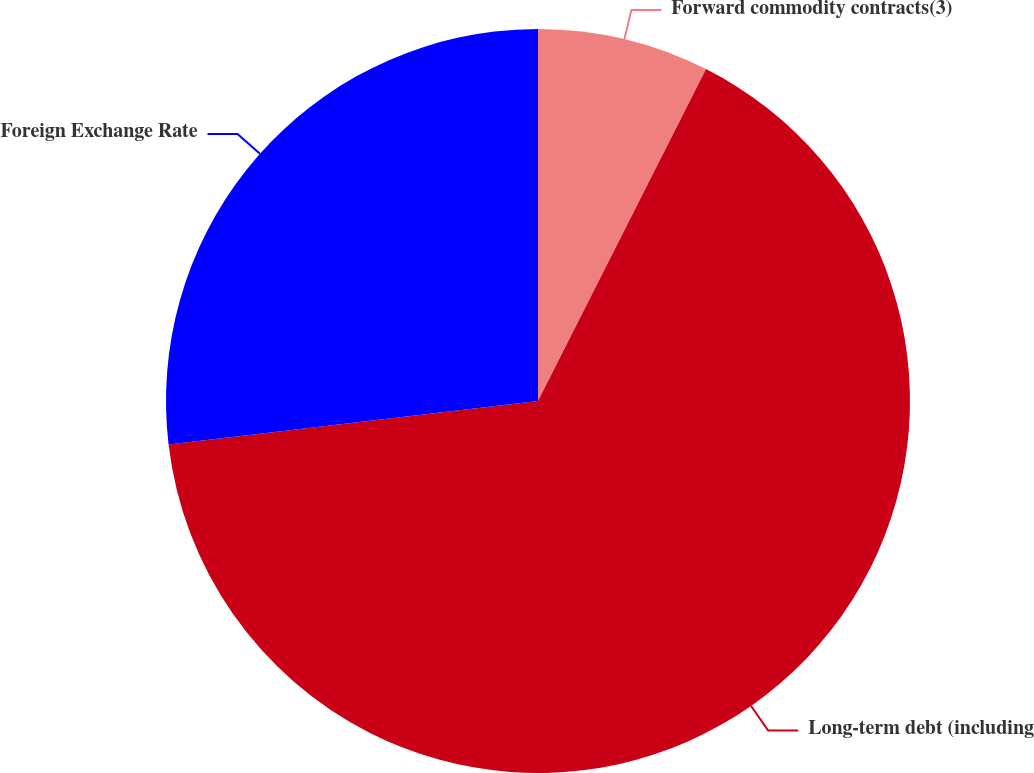Convert chart. <chart><loc_0><loc_0><loc_500><loc_500><pie_chart><fcel>Forward commodity contracts(3)<fcel>Long-term debt (including<fcel>Foreign Exchange Rate<nl><fcel>7.46%<fcel>65.67%<fcel>26.87%<nl></chart> 